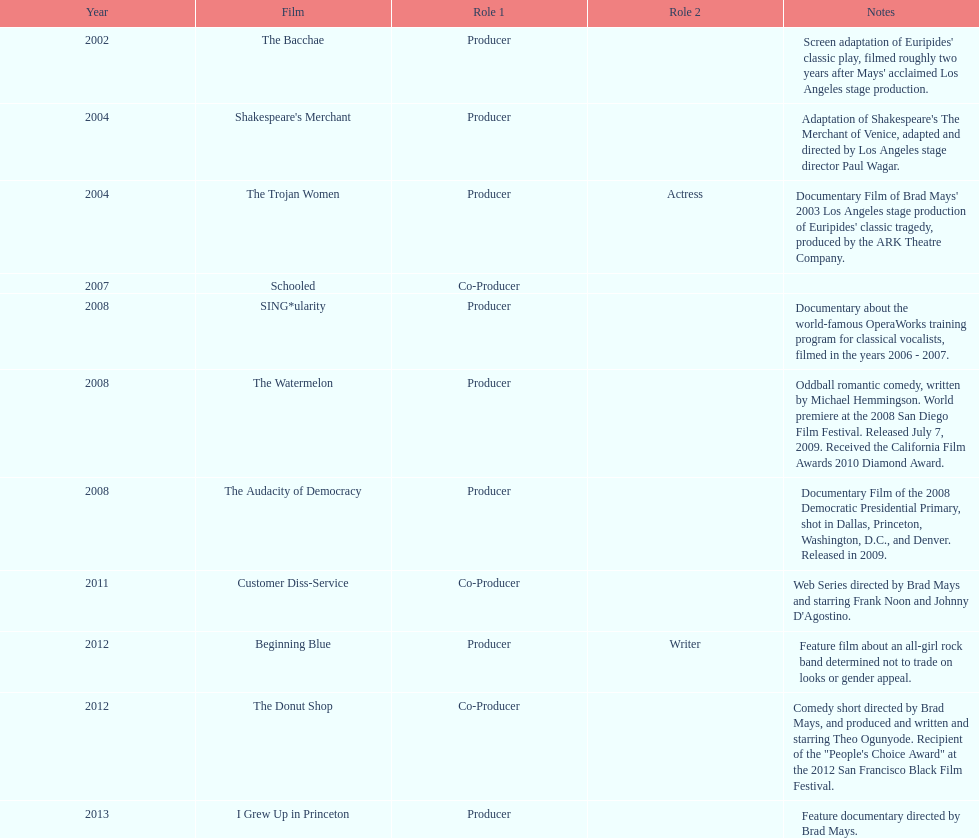In which year did ms. starfelt produce the most films? 2008. 